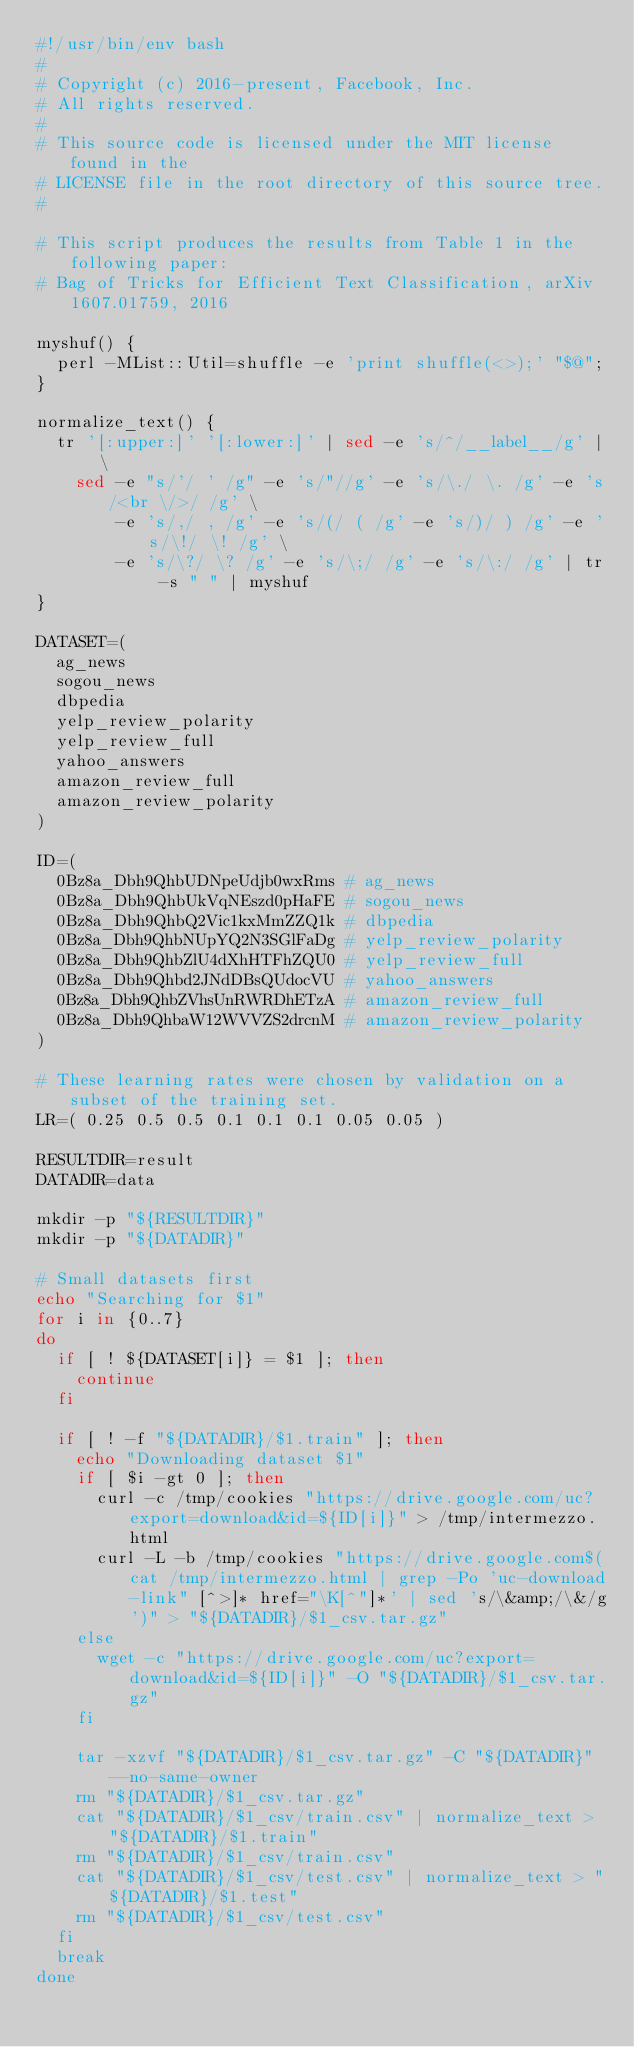<code> <loc_0><loc_0><loc_500><loc_500><_Bash_>#!/usr/bin/env bash
#
# Copyright (c) 2016-present, Facebook, Inc.
# All rights reserved.
#
# This source code is licensed under the MIT license found in the
# LICENSE file in the root directory of this source tree.
#

# This script produces the results from Table 1 in the following paper:
# Bag of Tricks for Efficient Text Classification, arXiv 1607.01759, 2016

myshuf() {
  perl -MList::Util=shuffle -e 'print shuffle(<>);' "$@";
}

normalize_text() {
  tr '[:upper:]' '[:lower:]' | sed -e 's/^/__label__/g' | \
    sed -e "s/'/ ' /g" -e 's/"//g' -e 's/\./ \. /g' -e 's/<br \/>/ /g' \
        -e 's/,/ , /g' -e 's/(/ ( /g' -e 's/)/ ) /g' -e 's/\!/ \! /g' \
        -e 's/\?/ \? /g' -e 's/\;/ /g' -e 's/\:/ /g' | tr -s " " | myshuf
}

DATASET=(
  ag_news
  sogou_news
  dbpedia
  yelp_review_polarity
  yelp_review_full
  yahoo_answers
  amazon_review_full
  amazon_review_polarity
)

ID=(
  0Bz8a_Dbh9QhbUDNpeUdjb0wxRms # ag_news
  0Bz8a_Dbh9QhbUkVqNEszd0pHaFE # sogou_news
  0Bz8a_Dbh9QhbQ2Vic1kxMmZZQ1k # dbpedia
  0Bz8a_Dbh9QhbNUpYQ2N3SGlFaDg # yelp_review_polarity
  0Bz8a_Dbh9QhbZlU4dXhHTFhZQU0 # yelp_review_full
  0Bz8a_Dbh9Qhbd2JNdDBsQUdocVU # yahoo_answers
  0Bz8a_Dbh9QhbZVhsUnRWRDhETzA # amazon_review_full
  0Bz8a_Dbh9QhbaW12WVVZS2drcnM # amazon_review_polarity
)

# These learning rates were chosen by validation on a subset of the training set.
LR=( 0.25 0.5 0.5 0.1 0.1 0.1 0.05 0.05 )

RESULTDIR=result
DATADIR=data

mkdir -p "${RESULTDIR}"
mkdir -p "${DATADIR}"

# Small datasets first
echo "Searching for $1"
for i in {0..7}
do
  if [ ! ${DATASET[i]} = $1 ]; then
    continue
  fi

  if [ ! -f "${DATADIR}/$1.train" ]; then
    echo "Downloading dataset $1"
    if [ $i -gt 0 ]; then
      curl -c /tmp/cookies "https://drive.google.com/uc?export=download&id=${ID[i]}" > /tmp/intermezzo.html
      curl -L -b /tmp/cookies "https://drive.google.com$(cat /tmp/intermezzo.html | grep -Po 'uc-download-link" [^>]* href="\K[^"]*' | sed 's/\&amp;/\&/g')" > "${DATADIR}/$1_csv.tar.gz"
    else
      wget -c "https://drive.google.com/uc?export=download&id=${ID[i]}" -O "${DATADIR}/$1_csv.tar.gz"
    fi

    tar -xzvf "${DATADIR}/$1_csv.tar.gz" -C "${DATADIR}" --no-same-owner
    rm "${DATADIR}/$1_csv.tar.gz"
    cat "${DATADIR}/$1_csv/train.csv" | normalize_text > "${DATADIR}/$1.train"
    rm "${DATADIR}/$1_csv/train.csv"
    cat "${DATADIR}/$1_csv/test.csv" | normalize_text > "${DATADIR}/$1.test"
    rm "${DATADIR}/$1_csv/test.csv"
  fi
  break
done


</code> 